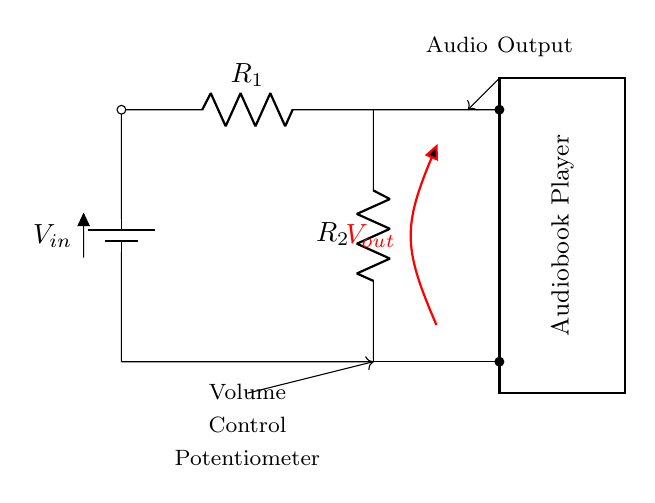What is the total resistance in this circuit? The total resistance in a voltage divider circuit is given by the formula R_total = R1 + R2. In this circuit, R1 and R2 are resistors connected in series.
Answer: R1 + R2 What is the purpose of the voltage divider? The purpose of the voltage divider in this circuit is to reduce the input voltage (Vin) to a lower output voltage (Vout) suitable for the audio playback, adjusting the volume level.
Answer: Adjust volume What component is used as a volume control? The volume control in this circuit is implemented using a potentiometer. This allows for variable adjustment of the output voltage based on user input.
Answer: Potentiometer What is the output voltage labeled as? The output voltage in this circuit is labeled as Vout, which represents the voltage across the second resistor and is the voltage delivered to the audiobook player.
Answer: Vout How many resistors are present in the circuit? The circuit contains two resistors, R1 and R2, which are used to form the voltage divider that adjusts the audio output.
Answer: Two What happens to Vout as R2 increases? As R2 increases, the Vout decreases. This is because a larger resistance in the voltage divider lowers the voltage drop across R2, resulting in a smaller output voltage.
Answer: Vout decreases 